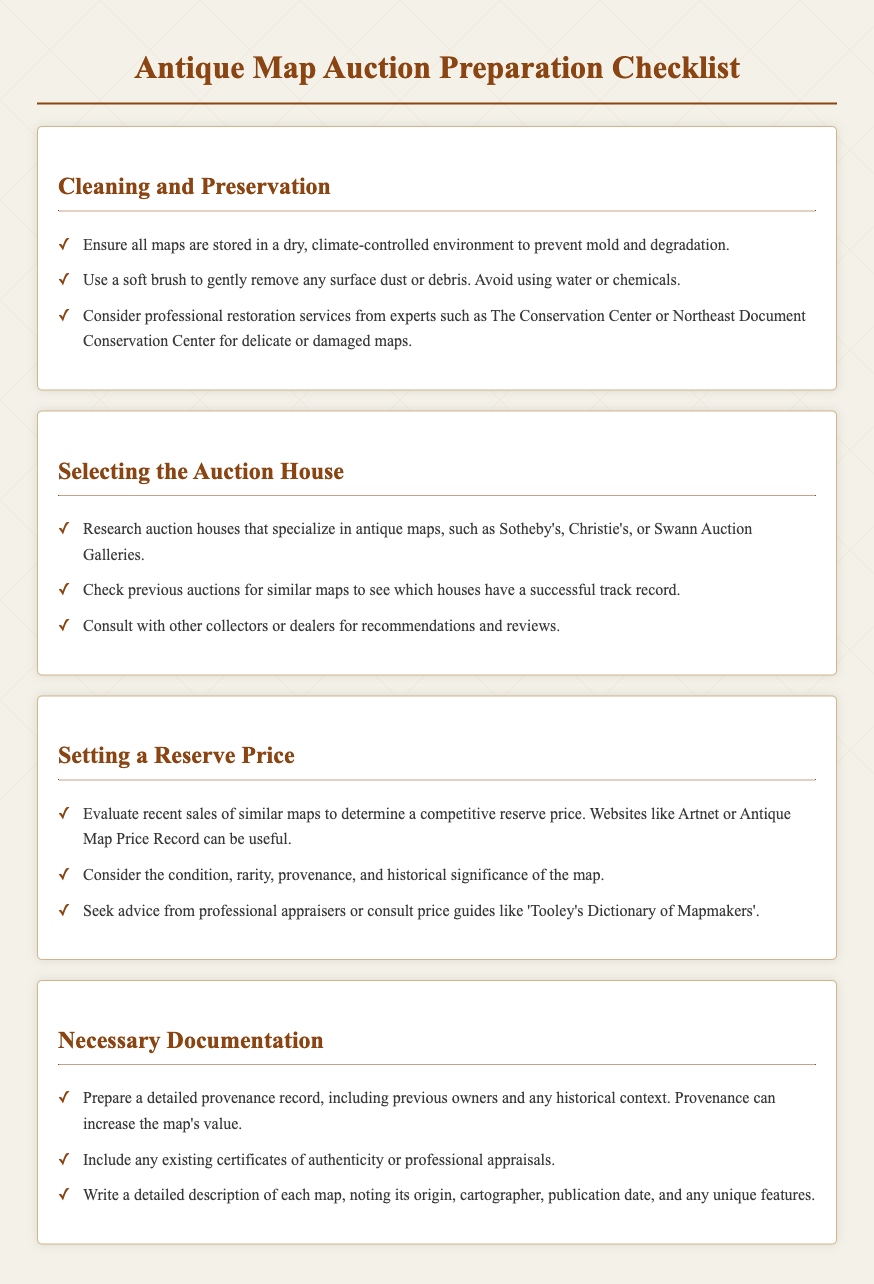what is the main title of the document? The main title at the top of the rendered document is prominently displayed as "Antique Map Auction Preparation Checklist."
Answer: Antique Map Auction Preparation Checklist how many sections are in the checklist? The document contains four distinct sections: Cleaning and Preservation, Selecting the Auction House, Setting a Reserve Price, and Necessary Documentation.
Answer: Four which auction houses are mentioned as examples? The checklist mentions specific auction houses which are known for antique maps: Sotheby's, Christie's, and Swann Auction Galleries.
Answer: Sotheby's, Christie's, Swann Auction Galleries what is an important consideration when cleaning maps? The checklist advises against using water or chemicals when cleaning maps, suggesting a gentle method instead.
Answer: Use a soft brush what can increase the map's value according to the checklist? The document states that a detailed provenance record can increase the map's value by providing context about its previous owners.
Answer: Provenance record what factors should be considered when setting a reserve price? The checklist highlights several factors including condition, rarity, provenance, and historical significance when determining a reserve price.
Answer: Condition, rarity, provenance, historical significance which service is recommended for professional restoration of delicate maps? The document specifically recommends consulting with professional restoration services like The Conservation Center or Northeast Document Conservation Center.
Answer: The Conservation Center how should maps be stored to prevent degradation? The checklist emphasizes that maps should be stored in a dry, climate-controlled environment to prevent mold and degradation.
Answer: Dry, climate-controlled environment what type of documentation should be prepared for auctioning maps? A detailed provenance record, certificates of authenticity, and detailed descriptions are mentioned as necessary documentation for auctioning maps.
Answer: Detailed provenance record how can recent sales information be useful? Recent sales of similar maps can help determine a competitive reserve price, providing insight into market value.
Answer: Competitive reserve price 